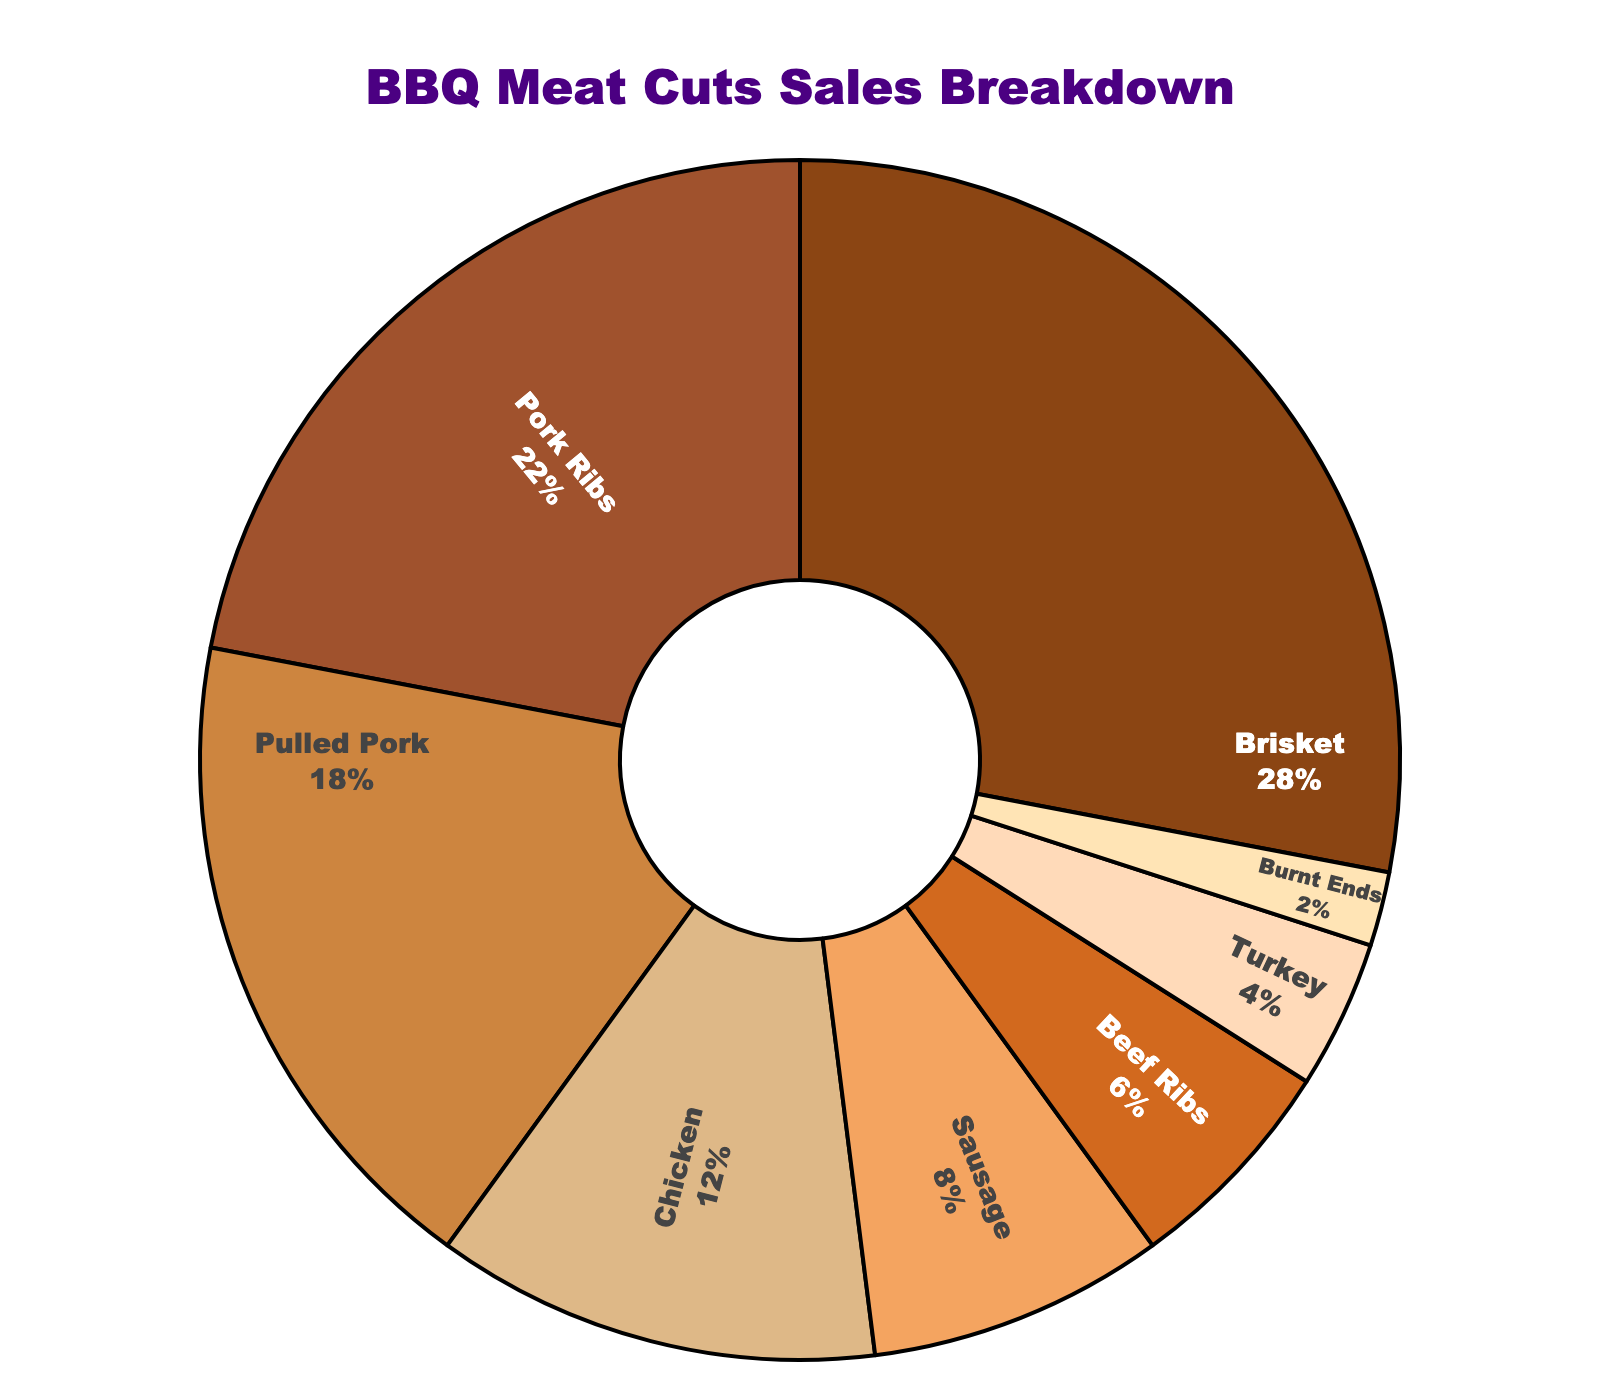What percentage of the total meat cuts sold are Brisket and Pork Ribs combined? To find the combined percentage, add the individual percentages of Brisket and Pork Ribs. Brisket is 28% and Pork Ribs are 22%. Thus, 28 + 22 = 50%.
Answer: 50% Which meat cut has the smallest percentage of sales? Look for the meat cut with the smallest percentage in the chart. Burnt Ends have the lowest value at 2%.
Answer: Burnt Ends Is the percentage of Sausage sold greater than, less than, or equal to the percentage of Chicken sold? Compare the percentages for Sausage and Chicken. Sausage is 8%, while Chicken is 12%. Since 8% is less than 12%, Sausage is less than Chicken.
Answer: Less than Is the percentage of Beef Ribs sold more than half of the total percentage of Pork Ribs sold? Check the value for Beef Ribs and compare it to half of the percentage of Pork Ribs. Beef Ribs is 6%, and half of Pork Ribs (22% / 2) is 11%. Since 6% is less than 11%, the percentage of Beef Ribs sold is not more than half of Pork Ribs sold.
Answer: No What is the total percentage of the meat cuts with less than 10% each? Identify the meat cuts with percentages less than 10% and sum them up: Sausage (8%), Beef Ribs (6%), Turkey (4%), and Burnt Ends (2%). The total is 8 + 6 + 4 + 2 = 20%.
Answer: 20% Which meat cut has a higher percentage: Pulled Pork or Turkey? Compare the percentages for Pulled Pork and Turkey. Pulled Pork is 18%, while Turkey is 4%. Therefore, Pulled Pork has a higher percentage.
Answer: Pulled Pork What is the average percentage of sales for Chicken, Sausage, and Beef Ribs? Find the percentages for Chicken (12%), Sausage (8%), and Beef Ribs (6%), and calculate their average: (12 + 8 + 6) / 3 = 26 / 3 = approximately 8.67%.
Answer: 8.67% Compare the relative sizes of the sections for Brisket and Burnt Ends. Which one is larger visually, and how much larger is it percentage-wise? Brisket is 28%, and Burnt Ends are 2%. Visually, Brisket is larger. The difference in percentage is 28% - 2% = 26%.
Answer: Brisket, 26% 